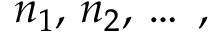Convert formula to latex. <formula><loc_0><loc_0><loc_500><loc_500>n _ { 1 } , \, n _ { 2 } , \, \dots \, ,</formula> 